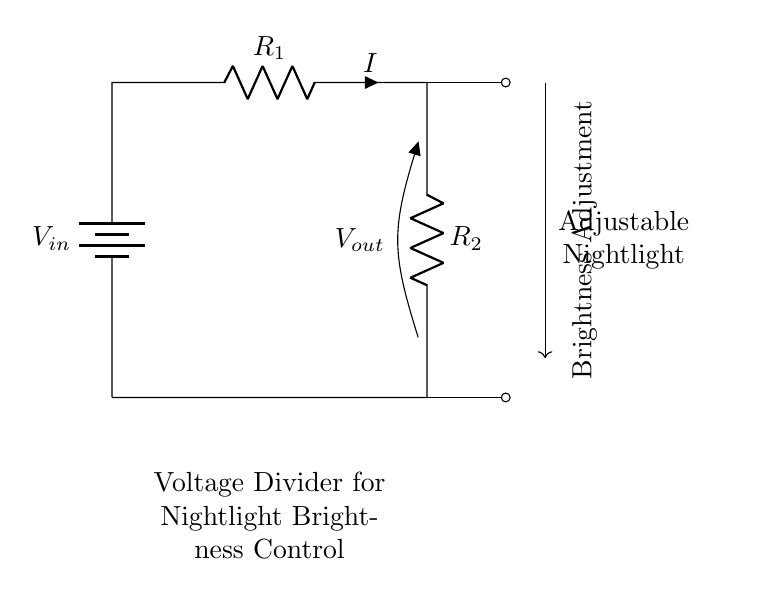What is the purpose of the resistors in this circuit? The resistors R1 and R2 are used to create a voltage divider, which allows for adjusting the output voltage (Vout) for controlling the brightness of the nightlight.
Answer: Adjust brightness What is the designation of the input voltage source? The input voltage source is labeled as Vin, indicating where the power supply voltage enters the circuit.
Answer: Vin What does Vout represent in the circuit? Vout represents the output voltage that is taken from the junction between the two resistors, which will be used to determine the brightness level of the nightlight.
Answer: Output voltage If R1 is twice the value of R2, how does the output voltage compare to Vin? If R1 is twice the value of R2, Vout will be one-third of Vin, since the voltage divider formula Vout = Vin * (R2 / (R1 + R2)) shows that the output voltage depends on the ratio of the resistances.
Answer: One-third of Vin Which component would you adjust to change the brightness? The circuit includes a mechanism to adjust the value of either resistor R1 or R2; however, typically adjusting R2 would directly influence Vout for brightness control.
Answer: R2 What type of circuit is this? This is a voltage divider circuit, specifically designed for adjusting the brightness of a light.
Answer: Voltage divider 